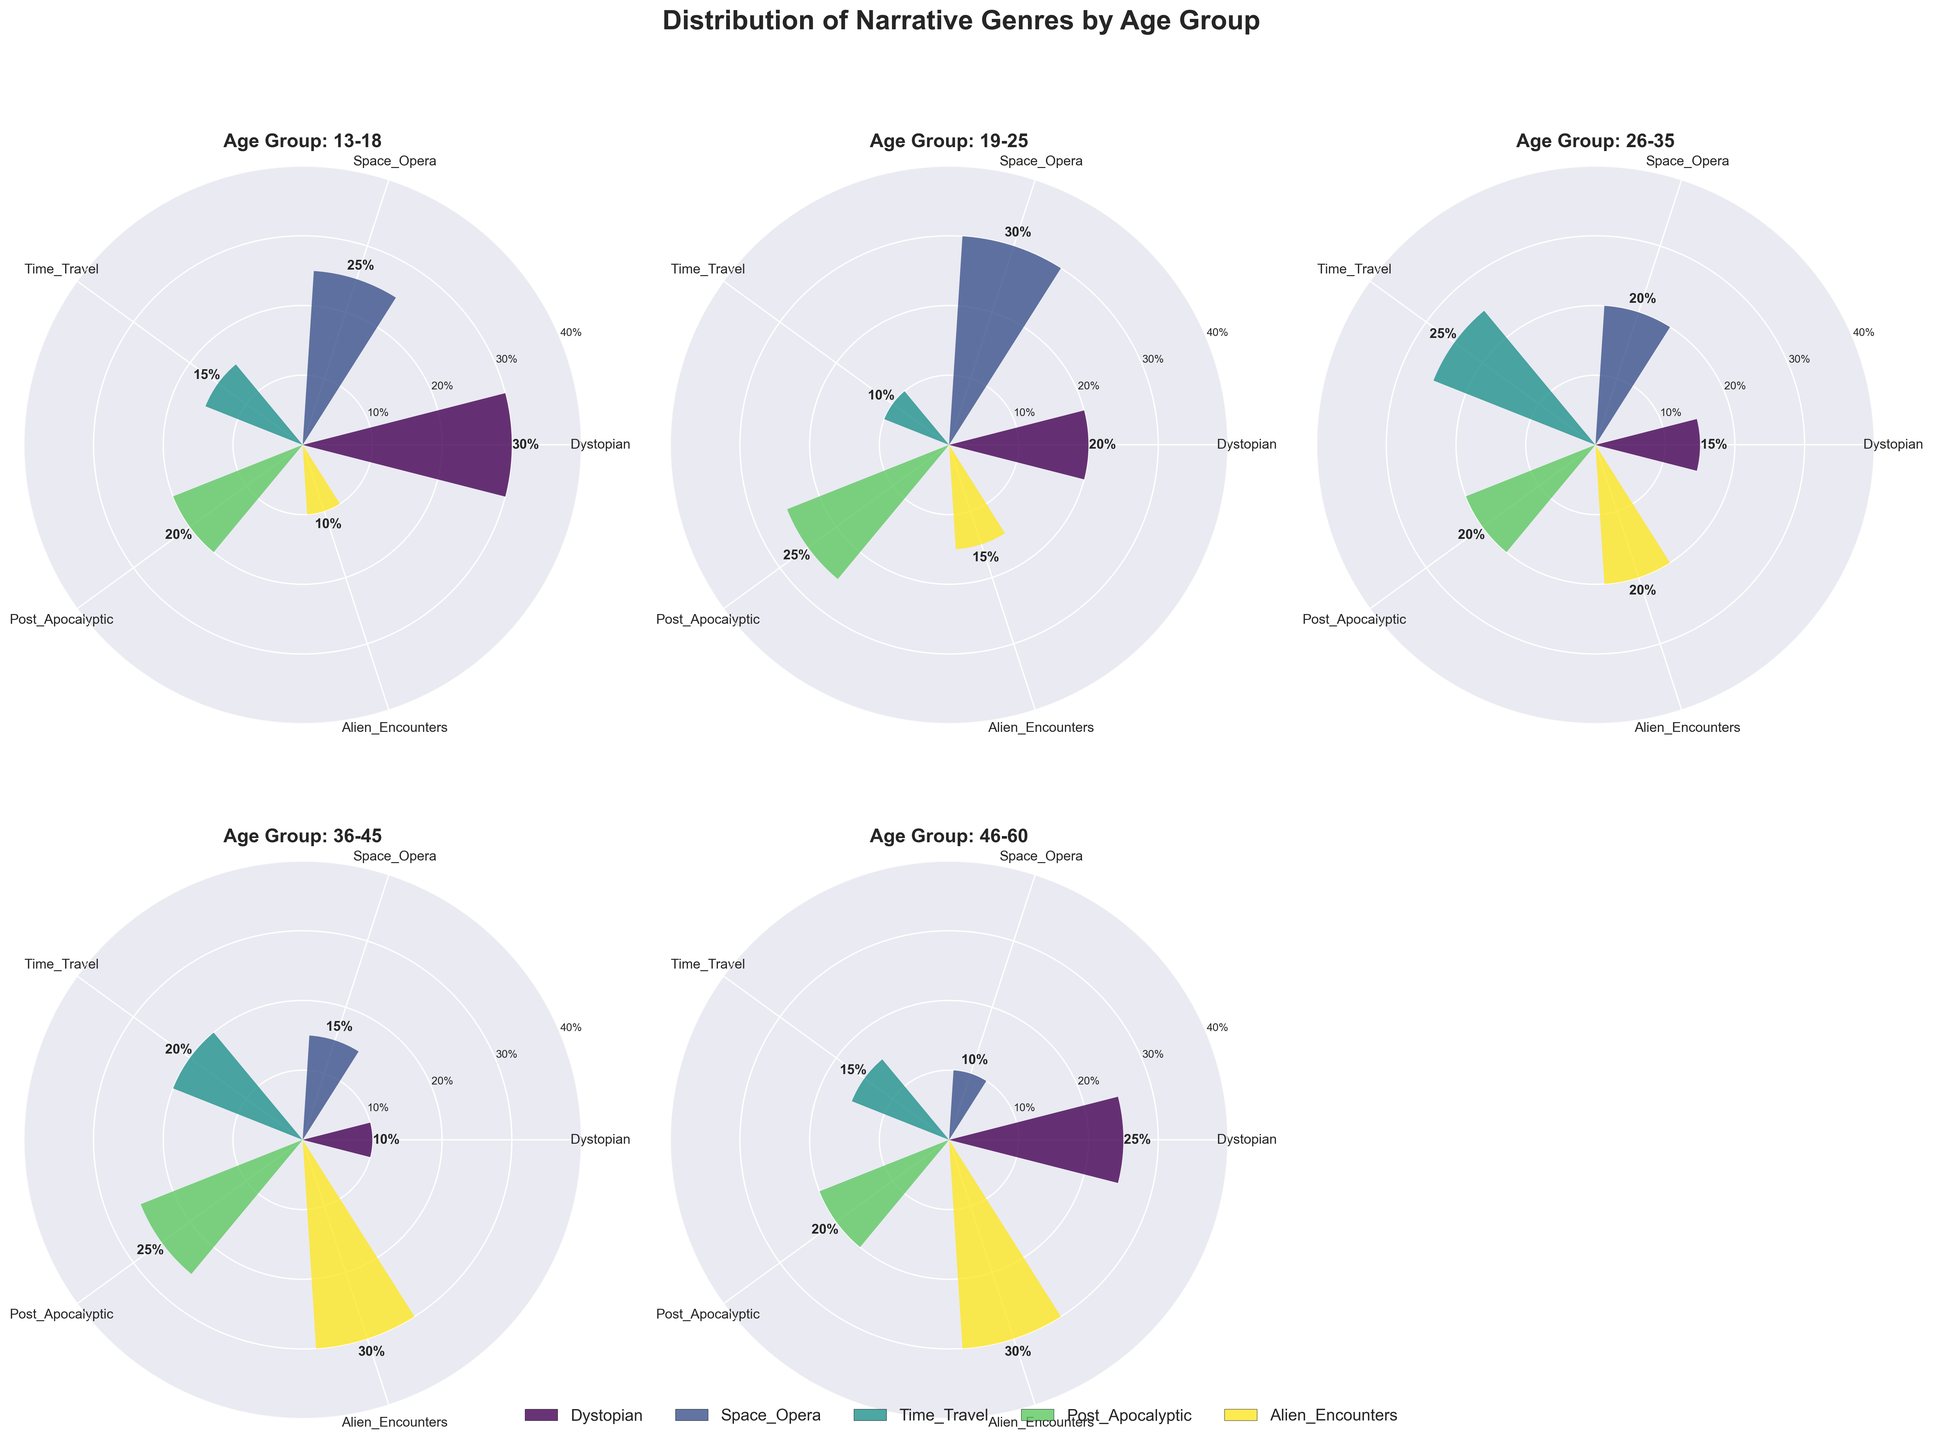What is the title of the figure? The title of the figure is located at the top center of the plot and is done in a large, bold font.
Answer: Distribution of Narrative Genres by Age Group Which narrative genre has the highest percentage for the age group 36-45? By inspecting the subplot labeled "Age Group: 36-45," we see that the bar for "Alien Encounters" reaches the highest percentage, labeled directly on the chart as 30%.
Answer: Alien Encounters How does the preference for Dystopian genres change across different age groups? In the subplots, check the Dystopian bar across age groups: 13-18 (30%), 19-25 (20%), 26-35 (15%), 36-45 (10%), and 46-60 (25%). The preference is highest in the age group 13-18 and increases again in 46-60.
Answer: Peaks at 13-18 and 46-60 Which age group has the lowest preference for Space Opera, and what is the percentage? By comparing the height of the Space Opera bars across all age group subplots, the age group 46-60 shows the lowest preference with the bar indicating 10%.
Answer: 46-60, 10% What are the combined percentages of Time Travel and Alien Encounters for the age group 26-35? Both Time Travel and Alien Encounters are 25% and 20%, respectively, in the subplot labeled "Age Group: 26-35." Adding them gives a combined percentage.
Answer: 45% In the age group 19-25, which narrative genre has the second-highest preference and what is the percentage? In the subplot for the age group 19-25, the bars show that Space Opera is the highest at 30%, while Post-Apocalyptic comes next at 25%.
Answer: Post-Apocalyptic, 25% Which age group shows the highest preference for Time Travel genres? Comparing the Time Travel bars across the age groups, the subplot for 26-35 shows the highest bar at 25%.
Answer: 26-35 How does the preference for Post-Apocalyptic compare between the age groups 13-18 and 19-25? Post-Apocalyptic preference is 20% for 13-18 and 25% for 19-25, which means it is higher in 19-25 by 5%.
Answer: Higher in 19-25 by 5% What is the average percentage preference for Alien Encounters across all age groups? Sum the percentages for Alien Encounters (10%, 15%, 20%, 30%, 30%) and divide by the number of age groups (5). The calculation is (10 + 15 + 20 + 30 + 30) / 5 = 21%.
Answer: 21% Which genre has the most stable preference across all age groups, defined as having the smallest range in percentages? Calculate the range (maximum - minimum) for each genre: Dystopian (30-10=20), Space Opera (30-10=20), Time Travel (25-10=15), Post-Apocalyptic (25-20=5), Alien Encounters (30-10=20). Post-Apocalyptic has the smallest range.
Answer: Post-Apocalyptic 